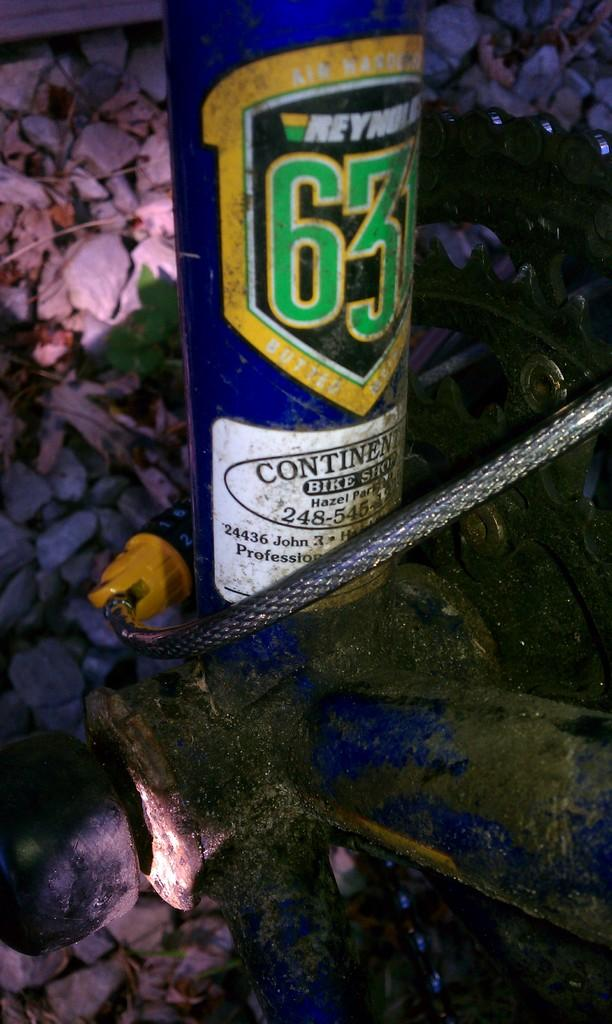<image>
Describe the image concisely. The bottle came from Continental Bike Shop in Hazel Park. 